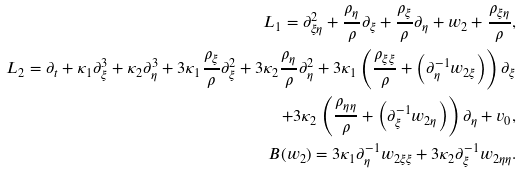<formula> <loc_0><loc_0><loc_500><loc_500>L _ { 1 } = \partial _ { \xi \eta } ^ { 2 } + \frac { \rho _ { \eta } } { \rho } \partial _ { \xi } + \frac { \rho _ { \xi } } { \rho } \partial _ { \eta } + w _ { 2 } + \frac { \rho _ { \xi \eta } } { \rho } , \\ L _ { 2 } = \partial _ { t } + \kappa _ { 1 } \partial _ { \xi } ^ { 3 } + \kappa _ { 2 } \partial _ { \eta } ^ { 3 } + 3 \kappa _ { 1 } \frac { \rho _ { \xi } } { \rho } \partial _ { \xi } ^ { 2 } + 3 \kappa _ { 2 } \frac { \rho _ { \eta } } { \rho } \partial _ { \eta } ^ { 2 } + 3 \kappa _ { 1 } \left ( \frac { \rho _ { \xi \xi } } { \rho } + \left ( \partial _ { \eta } ^ { - 1 } w _ { 2 \xi } \right ) \right ) \partial _ { \xi } \\ + 3 \kappa _ { 2 } \left ( \frac { \rho _ { \eta \eta } } { \rho } + \left ( \partial _ { \xi } ^ { - 1 } w _ { 2 \eta } \right ) \right ) \partial _ { \eta } + v _ { 0 } , \\ B ( w _ { 2 } ) = 3 \kappa _ { 1 } \partial _ { \eta } ^ { - 1 } w _ { 2 \xi \xi } + 3 \kappa _ { 2 } \partial _ { \xi } ^ { - 1 } w _ { 2 \eta \eta } .</formula> 